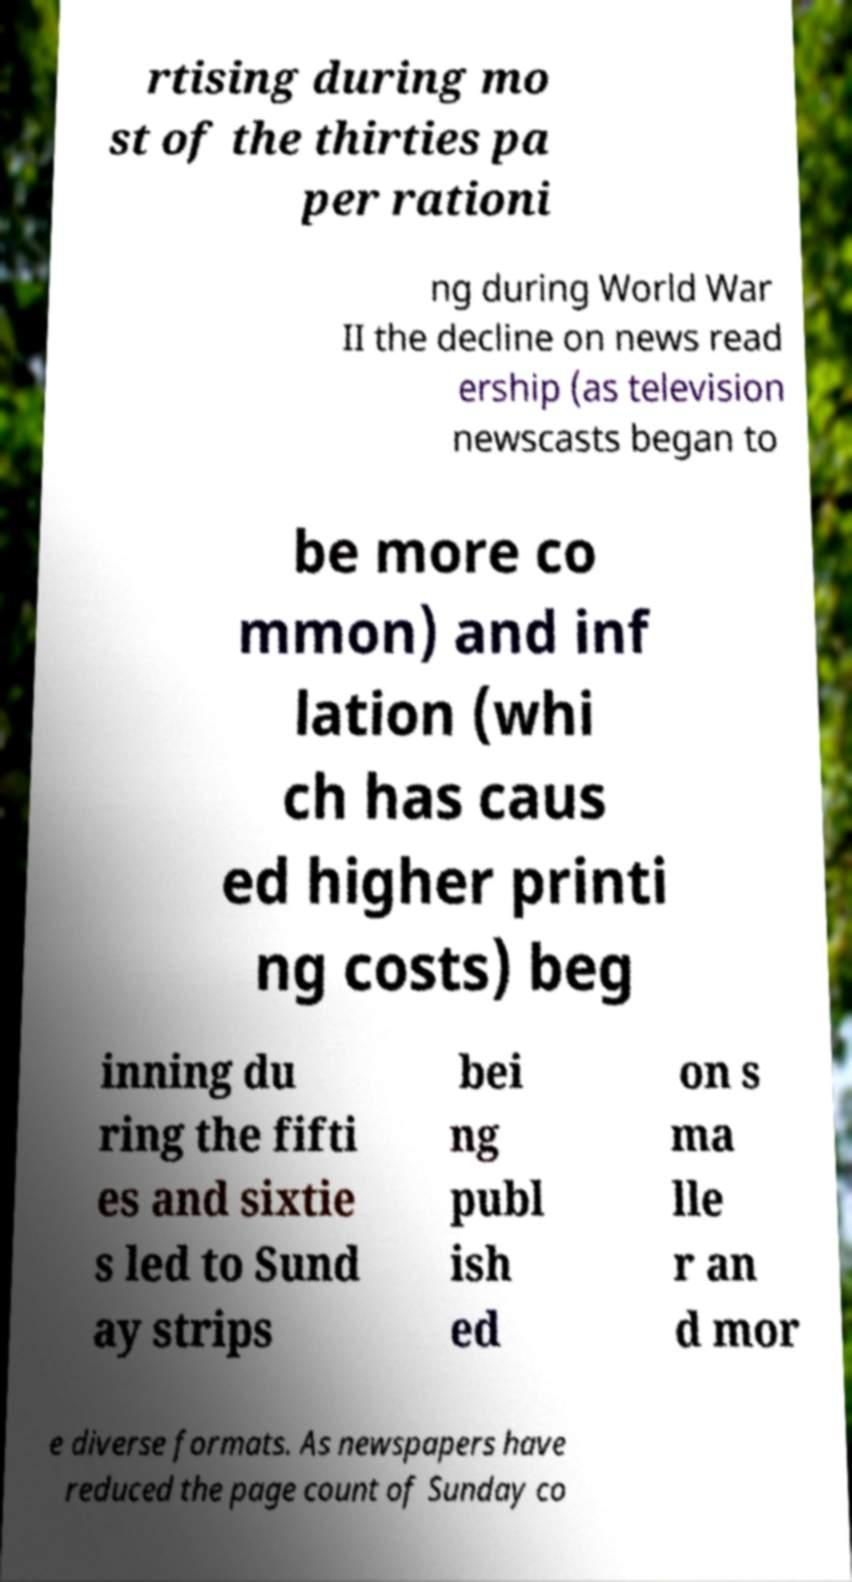Can you accurately transcribe the text from the provided image for me? rtising during mo st of the thirties pa per rationi ng during World War II the decline on news read ership (as television newscasts began to be more co mmon) and inf lation (whi ch has caus ed higher printi ng costs) beg inning du ring the fifti es and sixtie s led to Sund ay strips bei ng publ ish ed on s ma lle r an d mor e diverse formats. As newspapers have reduced the page count of Sunday co 